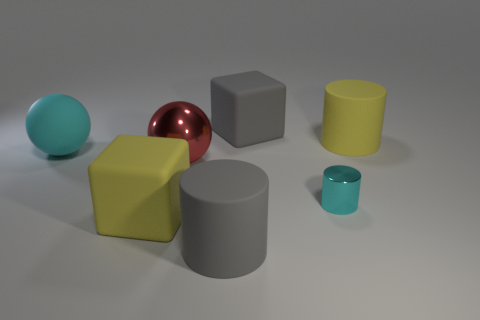Which objects in the image appear to be closest to the light source? Analyzing the image, it looks like the cyan sphere and the light gray cube are closest to the light source. You can tell because they have the brightest highlights and the sharpest, most defined shadows, indicating proximity to the light. 